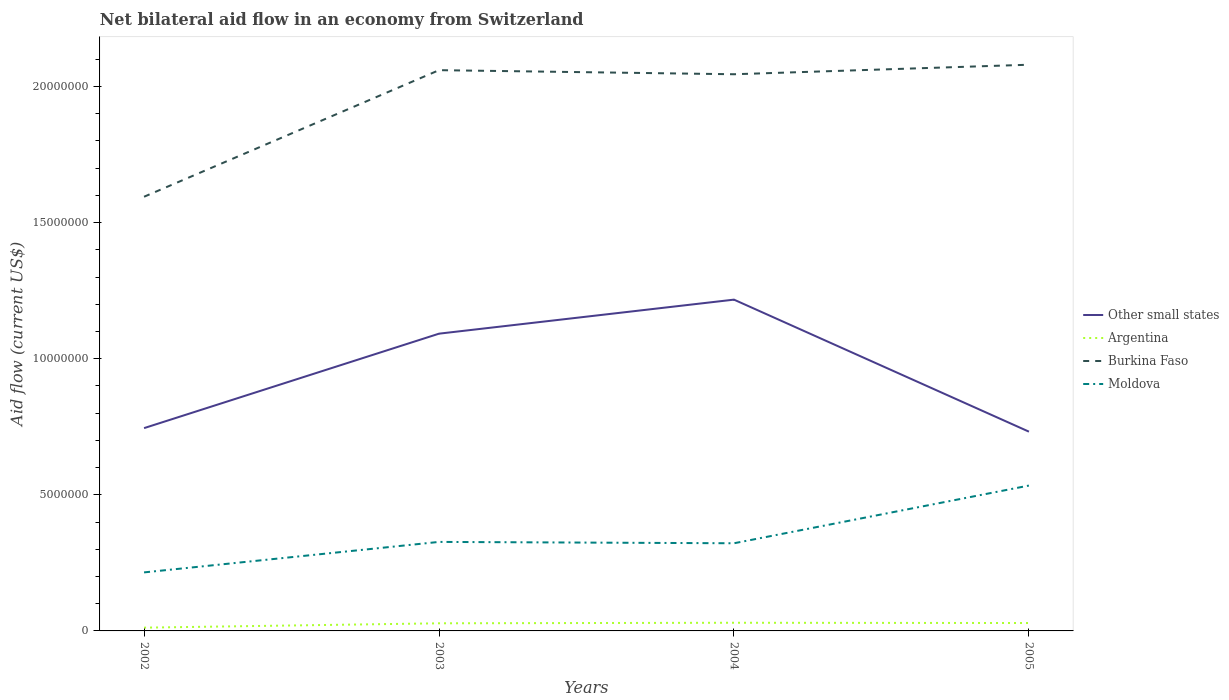How many different coloured lines are there?
Your answer should be very brief. 4. Does the line corresponding to Burkina Faso intersect with the line corresponding to Other small states?
Offer a very short reply. No. In which year was the net bilateral aid flow in Moldova maximum?
Your response must be concise. 2002. What is the total net bilateral aid flow in Other small states in the graph?
Offer a terse response. -1.25e+06. What is the difference between the highest and the second highest net bilateral aid flow in Burkina Faso?
Give a very brief answer. 4.85e+06. Is the net bilateral aid flow in Argentina strictly greater than the net bilateral aid flow in Other small states over the years?
Provide a short and direct response. Yes. How many lines are there?
Keep it short and to the point. 4. Does the graph contain any zero values?
Provide a succinct answer. No. How many legend labels are there?
Make the answer very short. 4. What is the title of the graph?
Provide a succinct answer. Net bilateral aid flow in an economy from Switzerland. What is the label or title of the X-axis?
Provide a short and direct response. Years. What is the label or title of the Y-axis?
Ensure brevity in your answer.  Aid flow (current US$). What is the Aid flow (current US$) in Other small states in 2002?
Your answer should be compact. 7.45e+06. What is the Aid flow (current US$) in Argentina in 2002?
Ensure brevity in your answer.  1.20e+05. What is the Aid flow (current US$) of Burkina Faso in 2002?
Ensure brevity in your answer.  1.60e+07. What is the Aid flow (current US$) of Moldova in 2002?
Offer a very short reply. 2.15e+06. What is the Aid flow (current US$) in Other small states in 2003?
Provide a succinct answer. 1.09e+07. What is the Aid flow (current US$) of Argentina in 2003?
Make the answer very short. 2.80e+05. What is the Aid flow (current US$) in Burkina Faso in 2003?
Make the answer very short. 2.06e+07. What is the Aid flow (current US$) of Moldova in 2003?
Provide a short and direct response. 3.27e+06. What is the Aid flow (current US$) in Other small states in 2004?
Your response must be concise. 1.22e+07. What is the Aid flow (current US$) of Argentina in 2004?
Your answer should be very brief. 3.00e+05. What is the Aid flow (current US$) in Burkina Faso in 2004?
Keep it short and to the point. 2.04e+07. What is the Aid flow (current US$) in Moldova in 2004?
Offer a very short reply. 3.22e+06. What is the Aid flow (current US$) in Other small states in 2005?
Offer a very short reply. 7.32e+06. What is the Aid flow (current US$) of Argentina in 2005?
Make the answer very short. 2.90e+05. What is the Aid flow (current US$) of Burkina Faso in 2005?
Provide a short and direct response. 2.08e+07. What is the Aid flow (current US$) in Moldova in 2005?
Your answer should be very brief. 5.34e+06. Across all years, what is the maximum Aid flow (current US$) of Other small states?
Make the answer very short. 1.22e+07. Across all years, what is the maximum Aid flow (current US$) of Burkina Faso?
Keep it short and to the point. 2.08e+07. Across all years, what is the maximum Aid flow (current US$) in Moldova?
Provide a succinct answer. 5.34e+06. Across all years, what is the minimum Aid flow (current US$) in Other small states?
Provide a succinct answer. 7.32e+06. Across all years, what is the minimum Aid flow (current US$) in Argentina?
Keep it short and to the point. 1.20e+05. Across all years, what is the minimum Aid flow (current US$) in Burkina Faso?
Your answer should be compact. 1.60e+07. Across all years, what is the minimum Aid flow (current US$) in Moldova?
Your answer should be compact. 2.15e+06. What is the total Aid flow (current US$) of Other small states in the graph?
Offer a very short reply. 3.79e+07. What is the total Aid flow (current US$) in Argentina in the graph?
Offer a terse response. 9.90e+05. What is the total Aid flow (current US$) in Burkina Faso in the graph?
Your response must be concise. 7.78e+07. What is the total Aid flow (current US$) of Moldova in the graph?
Your response must be concise. 1.40e+07. What is the difference between the Aid flow (current US$) of Other small states in 2002 and that in 2003?
Your response must be concise. -3.47e+06. What is the difference between the Aid flow (current US$) of Argentina in 2002 and that in 2003?
Provide a succinct answer. -1.60e+05. What is the difference between the Aid flow (current US$) of Burkina Faso in 2002 and that in 2003?
Give a very brief answer. -4.65e+06. What is the difference between the Aid flow (current US$) in Moldova in 2002 and that in 2003?
Ensure brevity in your answer.  -1.12e+06. What is the difference between the Aid flow (current US$) in Other small states in 2002 and that in 2004?
Keep it short and to the point. -4.72e+06. What is the difference between the Aid flow (current US$) in Burkina Faso in 2002 and that in 2004?
Your answer should be very brief. -4.50e+06. What is the difference between the Aid flow (current US$) of Moldova in 2002 and that in 2004?
Your response must be concise. -1.07e+06. What is the difference between the Aid flow (current US$) of Other small states in 2002 and that in 2005?
Your answer should be compact. 1.30e+05. What is the difference between the Aid flow (current US$) of Argentina in 2002 and that in 2005?
Ensure brevity in your answer.  -1.70e+05. What is the difference between the Aid flow (current US$) of Burkina Faso in 2002 and that in 2005?
Your answer should be very brief. -4.85e+06. What is the difference between the Aid flow (current US$) of Moldova in 2002 and that in 2005?
Ensure brevity in your answer.  -3.19e+06. What is the difference between the Aid flow (current US$) of Other small states in 2003 and that in 2004?
Keep it short and to the point. -1.25e+06. What is the difference between the Aid flow (current US$) in Burkina Faso in 2003 and that in 2004?
Offer a very short reply. 1.50e+05. What is the difference between the Aid flow (current US$) of Moldova in 2003 and that in 2004?
Provide a short and direct response. 5.00e+04. What is the difference between the Aid flow (current US$) in Other small states in 2003 and that in 2005?
Your answer should be very brief. 3.60e+06. What is the difference between the Aid flow (current US$) in Argentina in 2003 and that in 2005?
Provide a succinct answer. -10000. What is the difference between the Aid flow (current US$) in Burkina Faso in 2003 and that in 2005?
Your answer should be compact. -2.00e+05. What is the difference between the Aid flow (current US$) of Moldova in 2003 and that in 2005?
Your answer should be very brief. -2.07e+06. What is the difference between the Aid flow (current US$) in Other small states in 2004 and that in 2005?
Give a very brief answer. 4.85e+06. What is the difference between the Aid flow (current US$) in Burkina Faso in 2004 and that in 2005?
Your answer should be very brief. -3.50e+05. What is the difference between the Aid flow (current US$) of Moldova in 2004 and that in 2005?
Provide a succinct answer. -2.12e+06. What is the difference between the Aid flow (current US$) of Other small states in 2002 and the Aid flow (current US$) of Argentina in 2003?
Make the answer very short. 7.17e+06. What is the difference between the Aid flow (current US$) in Other small states in 2002 and the Aid flow (current US$) in Burkina Faso in 2003?
Make the answer very short. -1.32e+07. What is the difference between the Aid flow (current US$) of Other small states in 2002 and the Aid flow (current US$) of Moldova in 2003?
Ensure brevity in your answer.  4.18e+06. What is the difference between the Aid flow (current US$) in Argentina in 2002 and the Aid flow (current US$) in Burkina Faso in 2003?
Keep it short and to the point. -2.05e+07. What is the difference between the Aid flow (current US$) of Argentina in 2002 and the Aid flow (current US$) of Moldova in 2003?
Keep it short and to the point. -3.15e+06. What is the difference between the Aid flow (current US$) in Burkina Faso in 2002 and the Aid flow (current US$) in Moldova in 2003?
Keep it short and to the point. 1.27e+07. What is the difference between the Aid flow (current US$) in Other small states in 2002 and the Aid flow (current US$) in Argentina in 2004?
Provide a short and direct response. 7.15e+06. What is the difference between the Aid flow (current US$) in Other small states in 2002 and the Aid flow (current US$) in Burkina Faso in 2004?
Your answer should be compact. -1.30e+07. What is the difference between the Aid flow (current US$) of Other small states in 2002 and the Aid flow (current US$) of Moldova in 2004?
Provide a succinct answer. 4.23e+06. What is the difference between the Aid flow (current US$) in Argentina in 2002 and the Aid flow (current US$) in Burkina Faso in 2004?
Your answer should be compact. -2.03e+07. What is the difference between the Aid flow (current US$) of Argentina in 2002 and the Aid flow (current US$) of Moldova in 2004?
Your response must be concise. -3.10e+06. What is the difference between the Aid flow (current US$) in Burkina Faso in 2002 and the Aid flow (current US$) in Moldova in 2004?
Offer a very short reply. 1.27e+07. What is the difference between the Aid flow (current US$) in Other small states in 2002 and the Aid flow (current US$) in Argentina in 2005?
Keep it short and to the point. 7.16e+06. What is the difference between the Aid flow (current US$) in Other small states in 2002 and the Aid flow (current US$) in Burkina Faso in 2005?
Your response must be concise. -1.34e+07. What is the difference between the Aid flow (current US$) of Other small states in 2002 and the Aid flow (current US$) of Moldova in 2005?
Give a very brief answer. 2.11e+06. What is the difference between the Aid flow (current US$) in Argentina in 2002 and the Aid flow (current US$) in Burkina Faso in 2005?
Ensure brevity in your answer.  -2.07e+07. What is the difference between the Aid flow (current US$) in Argentina in 2002 and the Aid flow (current US$) in Moldova in 2005?
Offer a very short reply. -5.22e+06. What is the difference between the Aid flow (current US$) in Burkina Faso in 2002 and the Aid flow (current US$) in Moldova in 2005?
Your answer should be compact. 1.06e+07. What is the difference between the Aid flow (current US$) of Other small states in 2003 and the Aid flow (current US$) of Argentina in 2004?
Offer a very short reply. 1.06e+07. What is the difference between the Aid flow (current US$) of Other small states in 2003 and the Aid flow (current US$) of Burkina Faso in 2004?
Make the answer very short. -9.53e+06. What is the difference between the Aid flow (current US$) of Other small states in 2003 and the Aid flow (current US$) of Moldova in 2004?
Your answer should be compact. 7.70e+06. What is the difference between the Aid flow (current US$) in Argentina in 2003 and the Aid flow (current US$) in Burkina Faso in 2004?
Keep it short and to the point. -2.02e+07. What is the difference between the Aid flow (current US$) in Argentina in 2003 and the Aid flow (current US$) in Moldova in 2004?
Offer a very short reply. -2.94e+06. What is the difference between the Aid flow (current US$) of Burkina Faso in 2003 and the Aid flow (current US$) of Moldova in 2004?
Give a very brief answer. 1.74e+07. What is the difference between the Aid flow (current US$) of Other small states in 2003 and the Aid flow (current US$) of Argentina in 2005?
Make the answer very short. 1.06e+07. What is the difference between the Aid flow (current US$) in Other small states in 2003 and the Aid flow (current US$) in Burkina Faso in 2005?
Make the answer very short. -9.88e+06. What is the difference between the Aid flow (current US$) in Other small states in 2003 and the Aid flow (current US$) in Moldova in 2005?
Provide a succinct answer. 5.58e+06. What is the difference between the Aid flow (current US$) in Argentina in 2003 and the Aid flow (current US$) in Burkina Faso in 2005?
Provide a succinct answer. -2.05e+07. What is the difference between the Aid flow (current US$) of Argentina in 2003 and the Aid flow (current US$) of Moldova in 2005?
Keep it short and to the point. -5.06e+06. What is the difference between the Aid flow (current US$) in Burkina Faso in 2003 and the Aid flow (current US$) in Moldova in 2005?
Provide a succinct answer. 1.53e+07. What is the difference between the Aid flow (current US$) in Other small states in 2004 and the Aid flow (current US$) in Argentina in 2005?
Keep it short and to the point. 1.19e+07. What is the difference between the Aid flow (current US$) in Other small states in 2004 and the Aid flow (current US$) in Burkina Faso in 2005?
Ensure brevity in your answer.  -8.63e+06. What is the difference between the Aid flow (current US$) in Other small states in 2004 and the Aid flow (current US$) in Moldova in 2005?
Your answer should be very brief. 6.83e+06. What is the difference between the Aid flow (current US$) in Argentina in 2004 and the Aid flow (current US$) in Burkina Faso in 2005?
Provide a succinct answer. -2.05e+07. What is the difference between the Aid flow (current US$) in Argentina in 2004 and the Aid flow (current US$) in Moldova in 2005?
Offer a very short reply. -5.04e+06. What is the difference between the Aid flow (current US$) of Burkina Faso in 2004 and the Aid flow (current US$) of Moldova in 2005?
Your answer should be very brief. 1.51e+07. What is the average Aid flow (current US$) of Other small states per year?
Offer a terse response. 9.46e+06. What is the average Aid flow (current US$) in Argentina per year?
Provide a short and direct response. 2.48e+05. What is the average Aid flow (current US$) in Burkina Faso per year?
Ensure brevity in your answer.  1.94e+07. What is the average Aid flow (current US$) in Moldova per year?
Your answer should be very brief. 3.50e+06. In the year 2002, what is the difference between the Aid flow (current US$) of Other small states and Aid flow (current US$) of Argentina?
Provide a short and direct response. 7.33e+06. In the year 2002, what is the difference between the Aid flow (current US$) of Other small states and Aid flow (current US$) of Burkina Faso?
Keep it short and to the point. -8.50e+06. In the year 2002, what is the difference between the Aid flow (current US$) of Other small states and Aid flow (current US$) of Moldova?
Offer a terse response. 5.30e+06. In the year 2002, what is the difference between the Aid flow (current US$) of Argentina and Aid flow (current US$) of Burkina Faso?
Provide a succinct answer. -1.58e+07. In the year 2002, what is the difference between the Aid flow (current US$) of Argentina and Aid flow (current US$) of Moldova?
Your answer should be very brief. -2.03e+06. In the year 2002, what is the difference between the Aid flow (current US$) of Burkina Faso and Aid flow (current US$) of Moldova?
Your answer should be compact. 1.38e+07. In the year 2003, what is the difference between the Aid flow (current US$) in Other small states and Aid flow (current US$) in Argentina?
Your answer should be very brief. 1.06e+07. In the year 2003, what is the difference between the Aid flow (current US$) of Other small states and Aid flow (current US$) of Burkina Faso?
Your answer should be compact. -9.68e+06. In the year 2003, what is the difference between the Aid flow (current US$) of Other small states and Aid flow (current US$) of Moldova?
Offer a very short reply. 7.65e+06. In the year 2003, what is the difference between the Aid flow (current US$) in Argentina and Aid flow (current US$) in Burkina Faso?
Make the answer very short. -2.03e+07. In the year 2003, what is the difference between the Aid flow (current US$) of Argentina and Aid flow (current US$) of Moldova?
Make the answer very short. -2.99e+06. In the year 2003, what is the difference between the Aid flow (current US$) in Burkina Faso and Aid flow (current US$) in Moldova?
Keep it short and to the point. 1.73e+07. In the year 2004, what is the difference between the Aid flow (current US$) of Other small states and Aid flow (current US$) of Argentina?
Make the answer very short. 1.19e+07. In the year 2004, what is the difference between the Aid flow (current US$) in Other small states and Aid flow (current US$) in Burkina Faso?
Make the answer very short. -8.28e+06. In the year 2004, what is the difference between the Aid flow (current US$) in Other small states and Aid flow (current US$) in Moldova?
Your response must be concise. 8.95e+06. In the year 2004, what is the difference between the Aid flow (current US$) of Argentina and Aid flow (current US$) of Burkina Faso?
Give a very brief answer. -2.02e+07. In the year 2004, what is the difference between the Aid flow (current US$) of Argentina and Aid flow (current US$) of Moldova?
Ensure brevity in your answer.  -2.92e+06. In the year 2004, what is the difference between the Aid flow (current US$) in Burkina Faso and Aid flow (current US$) in Moldova?
Make the answer very short. 1.72e+07. In the year 2005, what is the difference between the Aid flow (current US$) in Other small states and Aid flow (current US$) in Argentina?
Offer a very short reply. 7.03e+06. In the year 2005, what is the difference between the Aid flow (current US$) of Other small states and Aid flow (current US$) of Burkina Faso?
Make the answer very short. -1.35e+07. In the year 2005, what is the difference between the Aid flow (current US$) of Other small states and Aid flow (current US$) of Moldova?
Ensure brevity in your answer.  1.98e+06. In the year 2005, what is the difference between the Aid flow (current US$) in Argentina and Aid flow (current US$) in Burkina Faso?
Give a very brief answer. -2.05e+07. In the year 2005, what is the difference between the Aid flow (current US$) in Argentina and Aid flow (current US$) in Moldova?
Ensure brevity in your answer.  -5.05e+06. In the year 2005, what is the difference between the Aid flow (current US$) in Burkina Faso and Aid flow (current US$) in Moldova?
Make the answer very short. 1.55e+07. What is the ratio of the Aid flow (current US$) in Other small states in 2002 to that in 2003?
Ensure brevity in your answer.  0.68. What is the ratio of the Aid flow (current US$) in Argentina in 2002 to that in 2003?
Keep it short and to the point. 0.43. What is the ratio of the Aid flow (current US$) in Burkina Faso in 2002 to that in 2003?
Offer a very short reply. 0.77. What is the ratio of the Aid flow (current US$) in Moldova in 2002 to that in 2003?
Make the answer very short. 0.66. What is the ratio of the Aid flow (current US$) of Other small states in 2002 to that in 2004?
Your answer should be compact. 0.61. What is the ratio of the Aid flow (current US$) of Argentina in 2002 to that in 2004?
Make the answer very short. 0.4. What is the ratio of the Aid flow (current US$) in Burkina Faso in 2002 to that in 2004?
Give a very brief answer. 0.78. What is the ratio of the Aid flow (current US$) in Moldova in 2002 to that in 2004?
Your response must be concise. 0.67. What is the ratio of the Aid flow (current US$) in Other small states in 2002 to that in 2005?
Keep it short and to the point. 1.02. What is the ratio of the Aid flow (current US$) of Argentina in 2002 to that in 2005?
Provide a succinct answer. 0.41. What is the ratio of the Aid flow (current US$) of Burkina Faso in 2002 to that in 2005?
Your response must be concise. 0.77. What is the ratio of the Aid flow (current US$) of Moldova in 2002 to that in 2005?
Keep it short and to the point. 0.4. What is the ratio of the Aid flow (current US$) in Other small states in 2003 to that in 2004?
Ensure brevity in your answer.  0.9. What is the ratio of the Aid flow (current US$) of Burkina Faso in 2003 to that in 2004?
Provide a succinct answer. 1.01. What is the ratio of the Aid flow (current US$) of Moldova in 2003 to that in 2004?
Your answer should be compact. 1.02. What is the ratio of the Aid flow (current US$) in Other small states in 2003 to that in 2005?
Give a very brief answer. 1.49. What is the ratio of the Aid flow (current US$) in Argentina in 2003 to that in 2005?
Your answer should be compact. 0.97. What is the ratio of the Aid flow (current US$) of Burkina Faso in 2003 to that in 2005?
Your response must be concise. 0.99. What is the ratio of the Aid flow (current US$) in Moldova in 2003 to that in 2005?
Make the answer very short. 0.61. What is the ratio of the Aid flow (current US$) in Other small states in 2004 to that in 2005?
Give a very brief answer. 1.66. What is the ratio of the Aid flow (current US$) of Argentina in 2004 to that in 2005?
Your response must be concise. 1.03. What is the ratio of the Aid flow (current US$) in Burkina Faso in 2004 to that in 2005?
Provide a succinct answer. 0.98. What is the ratio of the Aid flow (current US$) of Moldova in 2004 to that in 2005?
Give a very brief answer. 0.6. What is the difference between the highest and the second highest Aid flow (current US$) in Other small states?
Provide a short and direct response. 1.25e+06. What is the difference between the highest and the second highest Aid flow (current US$) of Burkina Faso?
Your answer should be compact. 2.00e+05. What is the difference between the highest and the second highest Aid flow (current US$) of Moldova?
Your answer should be very brief. 2.07e+06. What is the difference between the highest and the lowest Aid flow (current US$) of Other small states?
Offer a very short reply. 4.85e+06. What is the difference between the highest and the lowest Aid flow (current US$) in Argentina?
Offer a very short reply. 1.80e+05. What is the difference between the highest and the lowest Aid flow (current US$) of Burkina Faso?
Keep it short and to the point. 4.85e+06. What is the difference between the highest and the lowest Aid flow (current US$) of Moldova?
Give a very brief answer. 3.19e+06. 